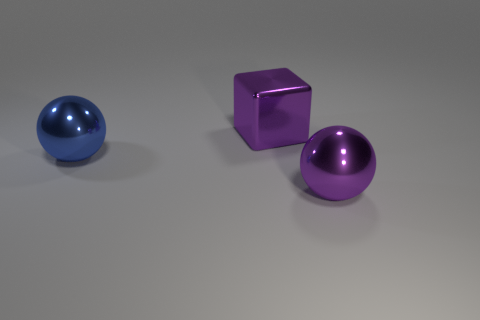Add 3 large things. How many objects exist? 6 Subtract all balls. How many objects are left? 1 Subtract 0 gray spheres. How many objects are left? 3 Subtract all gray shiny spheres. Subtract all blue things. How many objects are left? 2 Add 1 shiny balls. How many shiny balls are left? 3 Add 2 blue metallic objects. How many blue metallic objects exist? 3 